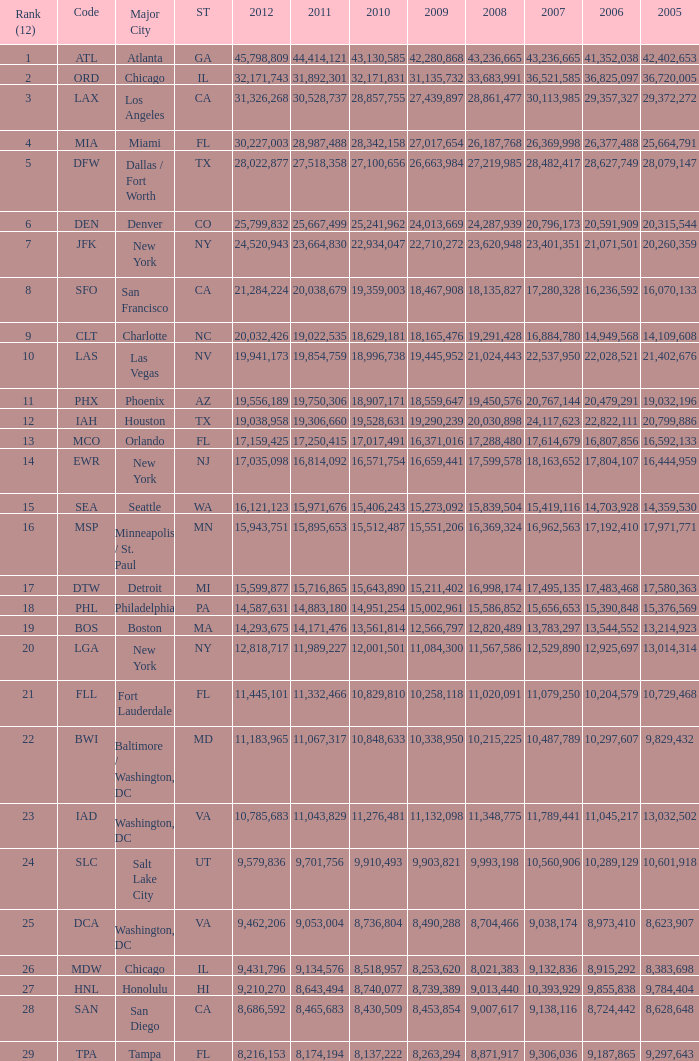For the IATA code of lax with 2009 less than 31,135,732 and 2011 less than 8,174,194, what is the sum of 2012? 0.0. 